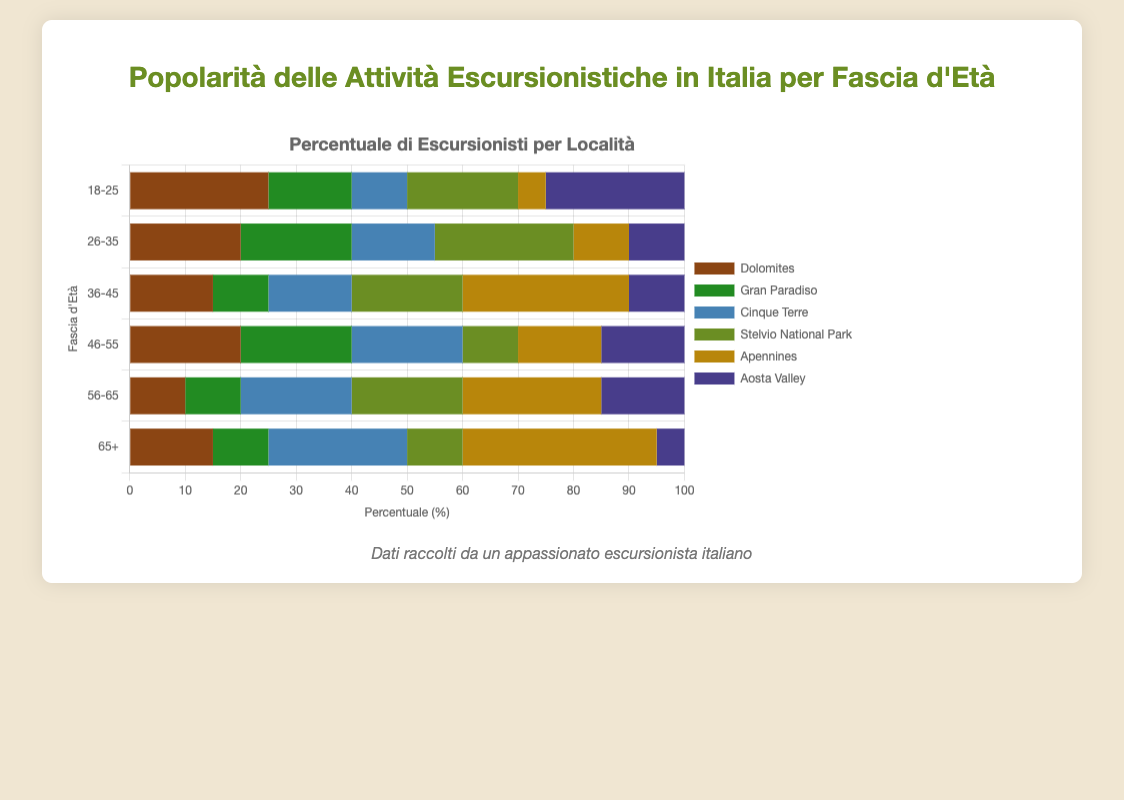What age group has the highest percentage for Dolomites? By observing the bars representing the Dolomites across all age groups, the longest bar is for the 18-25 age group. This indicates that the 18-25 age group has the highest percentage.
Answer: 18-25 Which location is the most popular among the age group 56-65? For the age group 56-65, the longest bar among all the bars is for the Apennines, indicating it is the most popular location.
Answer: Apennines How does the popularity of Cinque Terre change across age groups from 18-25 to 65+? By comparing the lengths of the bars representing Cinque Terre for each age group in ascending order, the popularity starting from 18-25 (shorter bar) increases steadily to its highest at 65+ (longest bar).
Answer: Increasing What is the combined percentage of hikers in Stelvio National Park for the age groups 26-35 and 36-45? The percentage for the age group 26-35 is 25, and for the age group 36-45 is 20. Adding these two values gives 25 + 20 = 45%.
Answer: 45% Which location shows the least popularity in the age group 46-55? For the age group 46-55, the smallest bar is for Stelvio National Park with 10%.
Answer: Stelvio National Park Compare the popularity of Aosta Valley between the age groups 18-25 and 65+. Which age group prefers it more? The bar for Aosta Valley is longer in the age group 18-25 (25%) compared to 65+ (5%). Therefore, the 18-25 age group prefers it more.
Answer: 18-25 What is the average popularity percentage of Gran Paradiso across all age groups? The percentages for Gran Paradiso across all age groups are 15, 20, 10, 20, 10, and 10. Adding these gives a total of 85. Dividing by the number of age groups, 85/6 ≈ 14.17%.
Answer: 14.17% Which age group has the highest combined percentage for the Dolomites and Aosta Valley? For the age group 18-25, the combined percentage for Dolomites and Aosta Valley is 25 + 25 = 50. For other groups: 26-35 (20+10=30), 36-45 (15+10=25), 46-55 (20+15=35), 56-65 (10+15=25), 65+ (15+5=20). Thus, the group 18-25 has the highest combined percentage at 50%.
Answer: 18-25 